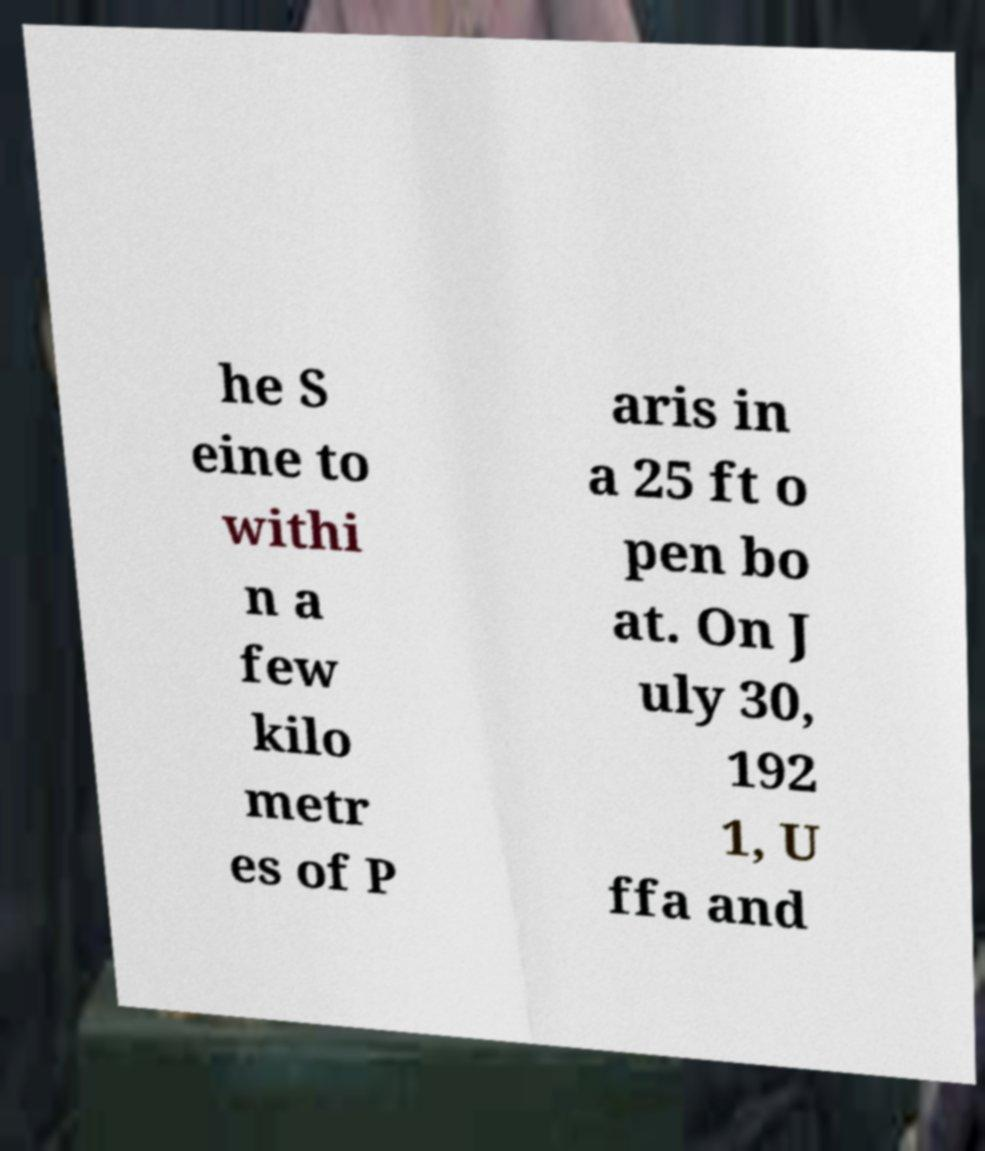Could you extract and type out the text from this image? he S eine to withi n a few kilo metr es of P aris in a 25 ft o pen bo at. On J uly 30, 192 1, U ffa and 